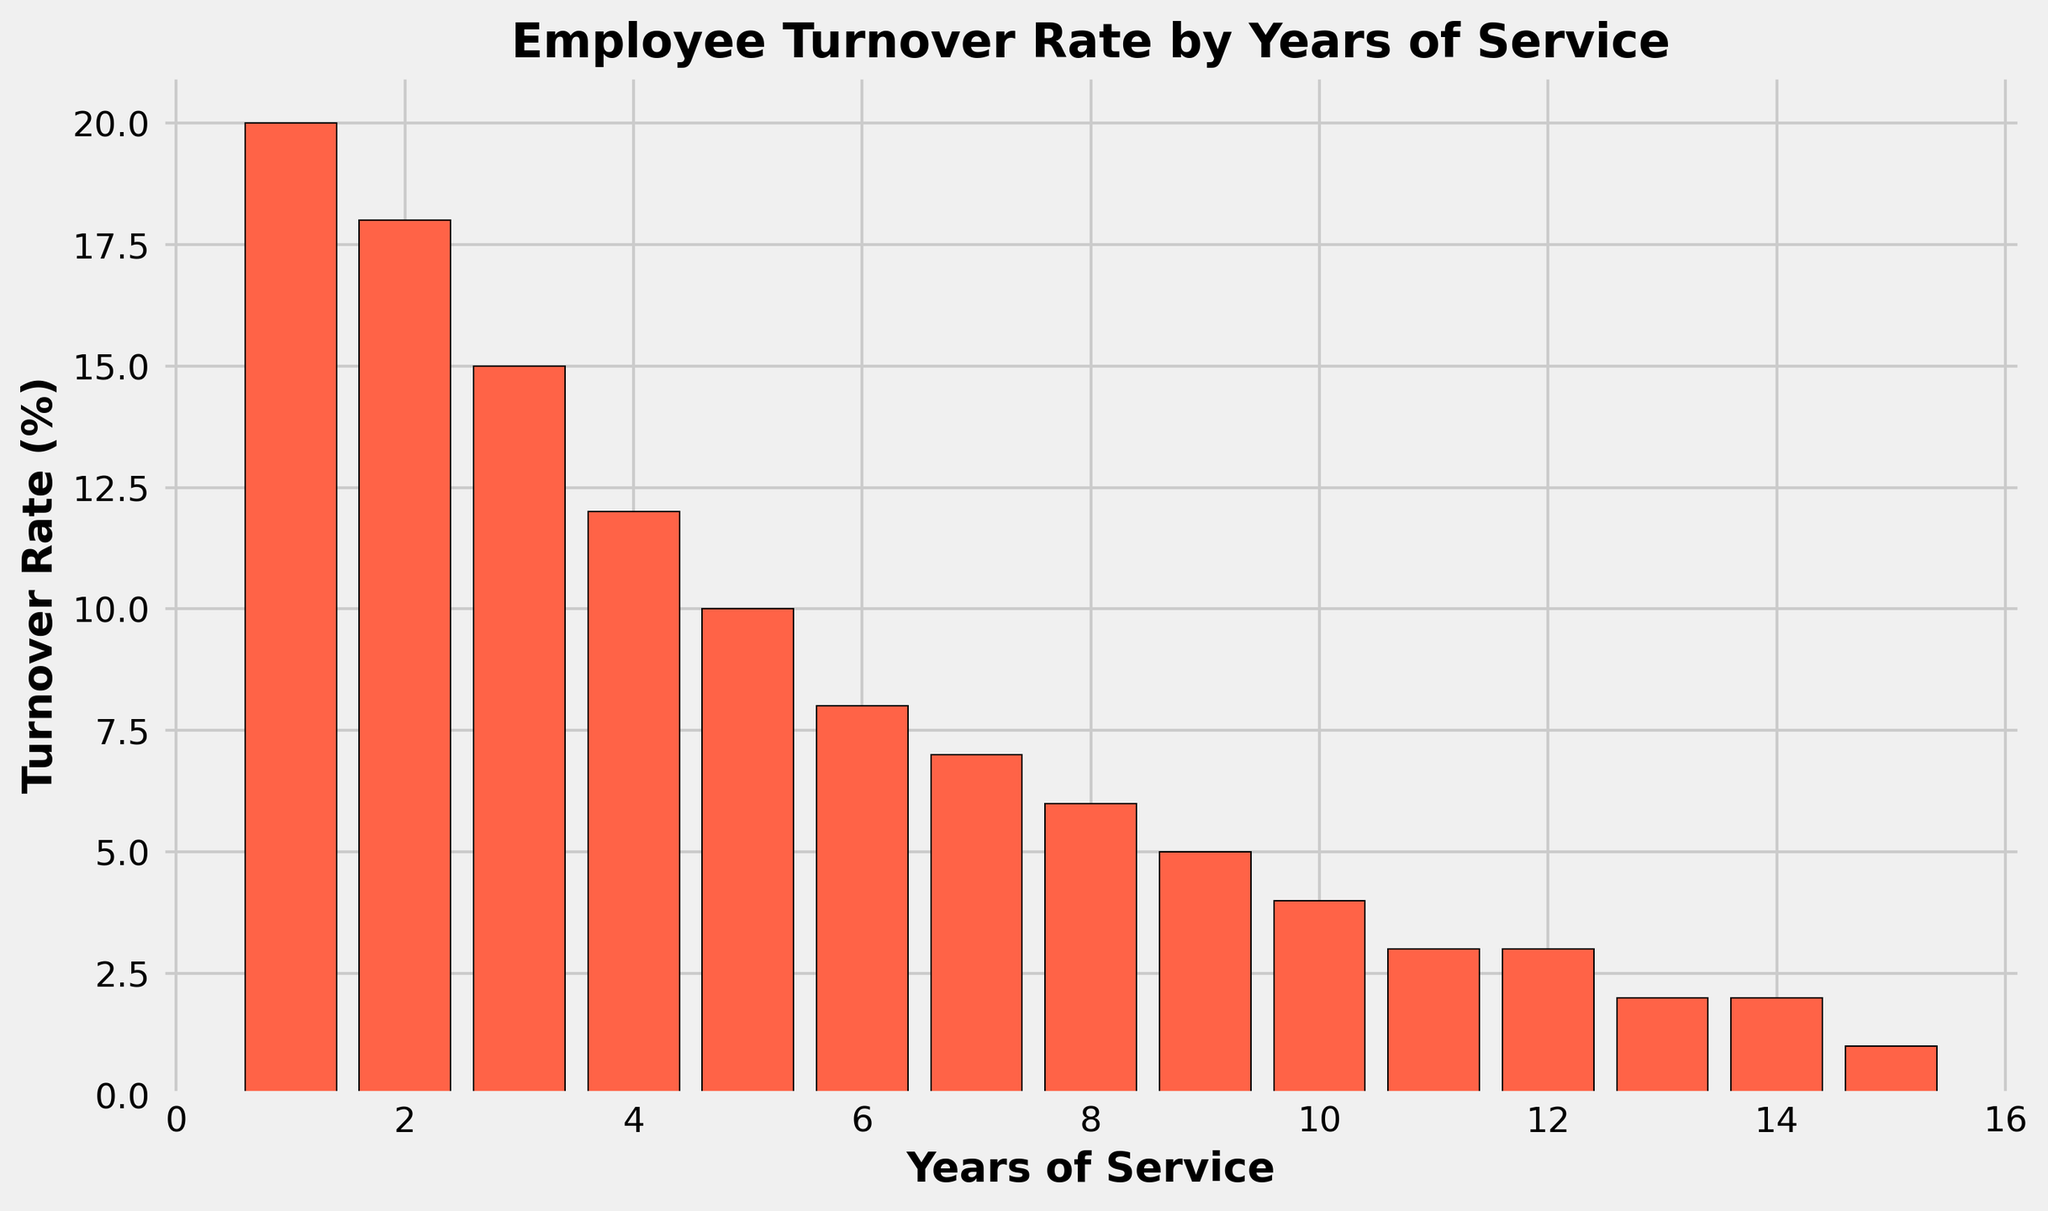What is the turnover rate for employees with 5 years of service? The bar corresponding to '5 years of service' has a height indicating a turnover rate of 10%.
Answer: 10% Which year of service has the highest turnover rate? The tallest bar on the figure represents the year of service with the highest turnover rate, which is 1 year of service with a rate of 20%.
Answer: 1 year Compare the turnover rates between 2 and 8 years of service. Which is higher? The turnover rate for 2 years of service is 18%, and for 8 years of service it is 6%. Therefore, the turnover rate at 2 years of service is higher.
Answer: 2 years How much does the turnover rate decrease from 1 year of service to 5 years? For 1 year of service, the turnover rate is 20%, and for 5 years it is 10%. The decrease is 20% - 10% = 10%.
Answer: 10% Which consecutive years have the smallest decrease in turnover rate? Observing the differences between consecutive years, the smallest decrease is between 11 and 12 years of service where both have the same turnover rate of 3%.
Answer: Between 11 and 12 years What is the average turnover rate for the first three years of service? The turnover rates for the first three years are 20%, 18%, and 15%. The sum is 20% + 18% + 15% = 53%, and the average is 53% / 3 = approximately 17.67%.
Answer: 17.67% By how much does the turnover rate decrease between 9 years and 15 years of service? The turnover rate for 9 years of service is 5%, and for 15 years it is 1%. The decrease is 5% - 1% = 4%.
Answer: 4% What trend can be observed from the turnover rates as years of service increase? Generally, the turnover rates decrease as years of service increase, with higher rates in the early years that progressively drop to very low rates by 15 years of service.
Answer: Decreasing trend Identify the point at which the turnover rate first drops to single digits. In which year does this happen? The turnover rate first drops to single digits at 6 years of service, where the rate is 8%.
Answer: 6 years Calculate the total turnover rate over 1 to 5 years of service. Sum the turnover rates from 1 to 5 years: 20% + 18% + 15% + 12% + 10% = 75%.
Answer: 75% 